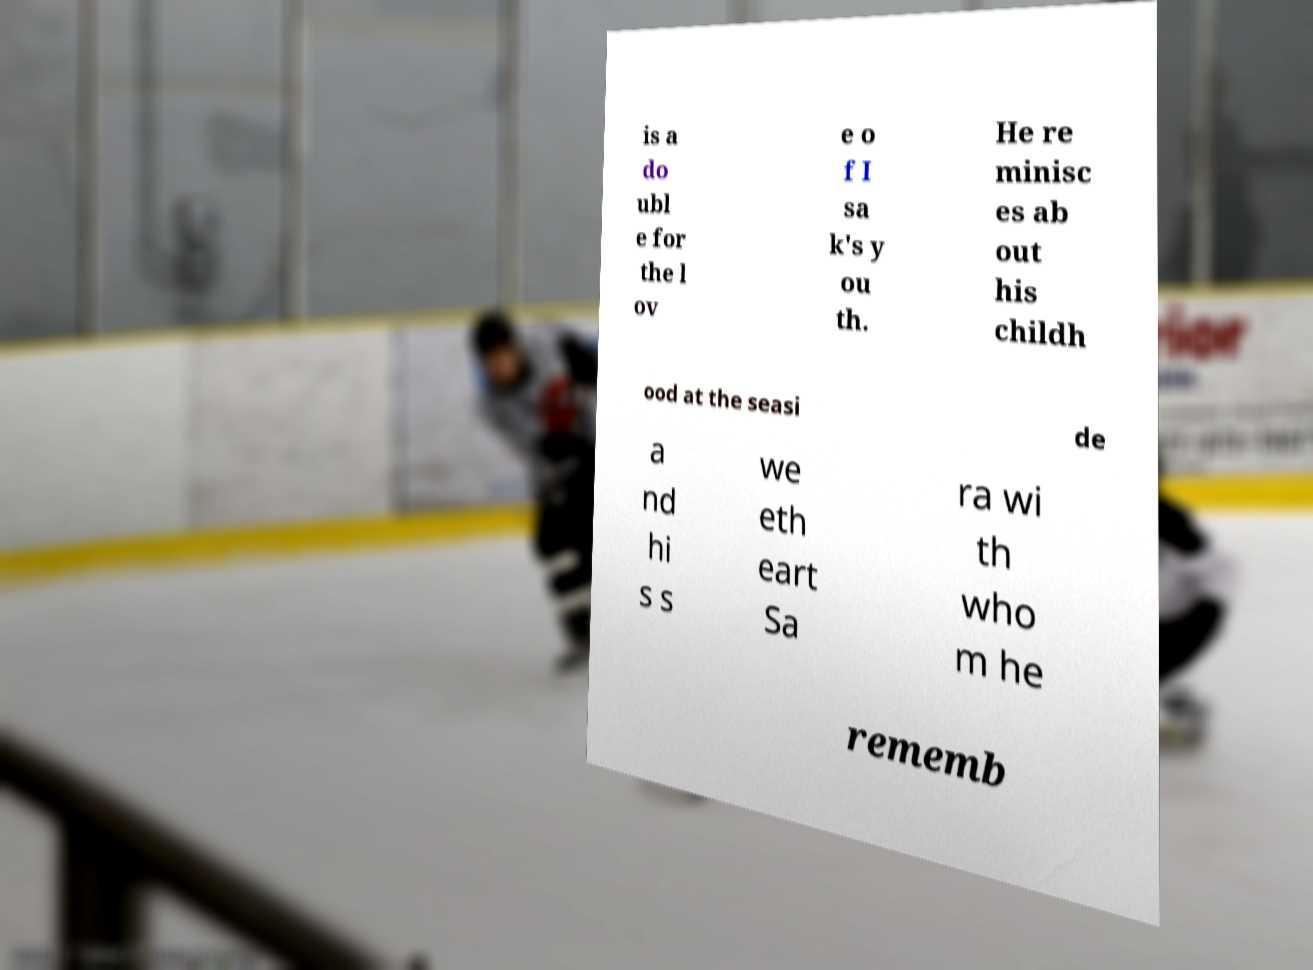Please read and relay the text visible in this image. What does it say? is a do ubl e for the l ov e o f I sa k's y ou th. He re minisc es ab out his childh ood at the seasi de a nd hi s s we eth eart Sa ra wi th who m he rememb 